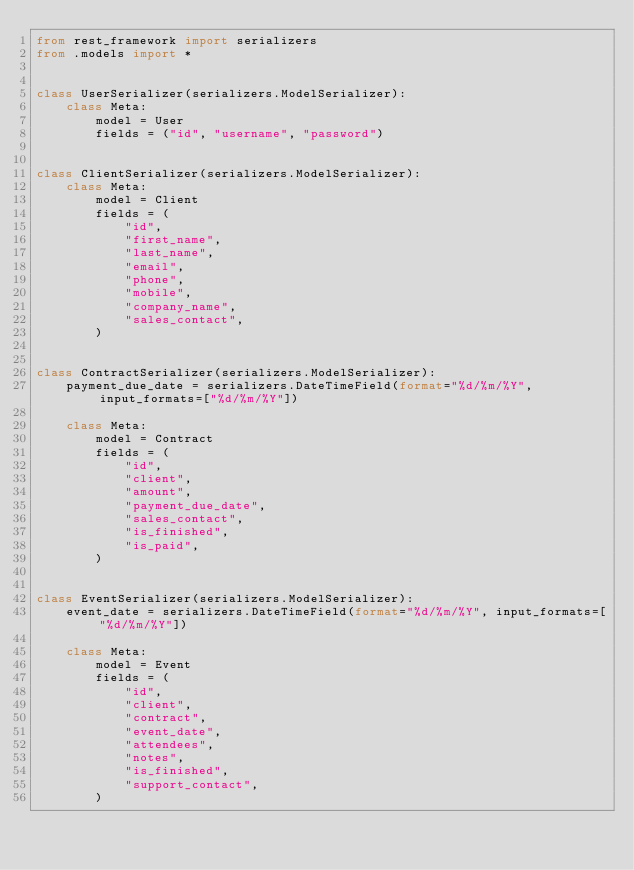<code> <loc_0><loc_0><loc_500><loc_500><_Python_>from rest_framework import serializers
from .models import *


class UserSerializer(serializers.ModelSerializer):
    class Meta:
        model = User
        fields = ("id", "username", "password")


class ClientSerializer(serializers.ModelSerializer):
    class Meta:
        model = Client
        fields = (
            "id",
            "first_name",
            "last_name",
            "email",
            "phone",
            "mobile",
            "company_name",
            "sales_contact",
        )


class ContractSerializer(serializers.ModelSerializer):
    payment_due_date = serializers.DateTimeField(format="%d/%m/%Y", input_formats=["%d/%m/%Y"])

    class Meta:
        model = Contract
        fields = (
            "id",
            "client",
            "amount",
            "payment_due_date",
            "sales_contact",
            "is_finished",
            "is_paid",
        )


class EventSerializer(serializers.ModelSerializer):
    event_date = serializers.DateTimeField(format="%d/%m/%Y", input_formats=["%d/%m/%Y"])

    class Meta:
        model = Event
        fields = (
            "id",
            "client",
            "contract",
            "event_date",
            "attendees",
            "notes",
            "is_finished",
            "support_contact",
        )
</code> 